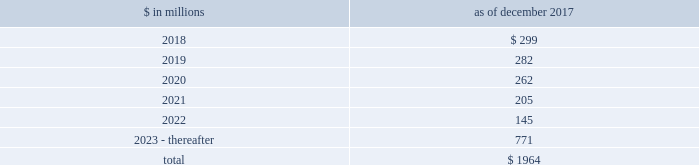The goldman sachs group , inc .
And subsidiaries notes to consolidated financial statements commercial lending .
The firm 2019s commercial lending commitments are extended to investment-grade and non-investment-grade corporate borrowers .
Commitments to investment-grade corporate borrowers are principally used for operating liquidity and general corporate purposes .
The firm also extends lending commitments in connection with contingent acquisition financing and other types of corporate lending , as well as commercial real estate financing .
Commitments that are extended for contingent acquisition financing are often intended to be short-term in nature , as borrowers often seek to replace them with other funding sources .
Sumitomo mitsui financial group , inc .
( smfg ) provides the firm with credit loss protection on certain approved loan commitments ( primarily investment-grade commercial lending commitments ) .
The notional amount of such loan commitments was $ 25.70 billion and $ 26.88 billion as of december 2017 and december 2016 , respectively .
The credit loss protection on loan commitments provided by smfg is generally limited to 95% ( 95 % ) of the first loss the firm realizes on such commitments , up to a maximum of approximately $ 950 million .
In addition , subject to the satisfaction of certain conditions , upon the firm 2019s request , smfg will provide protection for 70% ( 70 % ) of additional losses on such commitments , up to a maximum of $ 1.13 billion , of which $ 550 million and $ 768 million of protection had been provided as of december 2017 and december 2016 , respectively .
The firm also uses other financial instruments to mitigate credit risks related to certain commitments not covered by smfg .
These instruments primarily include credit default swaps that reference the same or similar underlying instrument or entity , or credit default swaps that reference a market index .
Warehouse financing .
The firm provides financing to clients who warehouse financial assets .
These arrangements are secured by the warehoused assets , primarily consisting of retail and corporate loans .
Contingent and forward starting collateralized agreements / forward starting collateralized financings contingent and forward starting collateralized agreements includes resale and securities borrowing agreements , and forward starting collateralized financings includes repurchase and secured lending agreements that settle at a future date , generally within three business days .
The firm also enters into commitments to provide contingent financing to its clients and counterparties through resale agreements .
The firm 2019s funding of these commitments depends on the satisfaction of all contractual conditions to the resale agreement and these commitments can expire unused .
Letters of credit the firm has commitments under letters of credit issued by various banks which the firm provides to counterparties in lieu of securities or cash to satisfy various collateral and margin deposit requirements .
Investment commitments investment commitments includes commitments to invest in private equity , real estate and other assets directly and through funds that the firm raises and manages .
Investment commitments included $ 2.09 billion and $ 2.10 billion as of december 2017 and december 2016 , respectively , related to commitments to invest in funds managed by the firm .
If these commitments are called , they would be funded at market value on the date of investment .
Leases the firm has contractual obligations under long-term noncancelable lease agreements for office space expiring on various dates through 2069 .
Certain agreements are subject to periodic escalation provisions for increases in real estate taxes and other charges .
The table below presents future minimum rental payments , net of minimum sublease rentals .
$ in millions december 2017 .
Rent charged to operating expenses was $ 273 million for 2017 , $ 244 million for 2016 and $ 249 million for 2015 .
Goldman sachs 2017 form 10-k 163 .
What percentage of future minimum rental payments are due after 2022? 
Computations: (771 / 1964)
Answer: 0.39257. The goldman sachs group , inc .
And subsidiaries notes to consolidated financial statements commercial lending .
The firm 2019s commercial lending commitments are extended to investment-grade and non-investment-grade corporate borrowers .
Commitments to investment-grade corporate borrowers are principally used for operating liquidity and general corporate purposes .
The firm also extends lending commitments in connection with contingent acquisition financing and other types of corporate lending , as well as commercial real estate financing .
Commitments that are extended for contingent acquisition financing are often intended to be short-term in nature , as borrowers often seek to replace them with other funding sources .
Sumitomo mitsui financial group , inc .
( smfg ) provides the firm with credit loss protection on certain approved loan commitments ( primarily investment-grade commercial lending commitments ) .
The notional amount of such loan commitments was $ 25.70 billion and $ 26.88 billion as of december 2017 and december 2016 , respectively .
The credit loss protection on loan commitments provided by smfg is generally limited to 95% ( 95 % ) of the first loss the firm realizes on such commitments , up to a maximum of approximately $ 950 million .
In addition , subject to the satisfaction of certain conditions , upon the firm 2019s request , smfg will provide protection for 70% ( 70 % ) of additional losses on such commitments , up to a maximum of $ 1.13 billion , of which $ 550 million and $ 768 million of protection had been provided as of december 2017 and december 2016 , respectively .
The firm also uses other financial instruments to mitigate credit risks related to certain commitments not covered by smfg .
These instruments primarily include credit default swaps that reference the same or similar underlying instrument or entity , or credit default swaps that reference a market index .
Warehouse financing .
The firm provides financing to clients who warehouse financial assets .
These arrangements are secured by the warehoused assets , primarily consisting of retail and corporate loans .
Contingent and forward starting collateralized agreements / forward starting collateralized financings contingent and forward starting collateralized agreements includes resale and securities borrowing agreements , and forward starting collateralized financings includes repurchase and secured lending agreements that settle at a future date , generally within three business days .
The firm also enters into commitments to provide contingent financing to its clients and counterparties through resale agreements .
The firm 2019s funding of these commitments depends on the satisfaction of all contractual conditions to the resale agreement and these commitments can expire unused .
Letters of credit the firm has commitments under letters of credit issued by various banks which the firm provides to counterparties in lieu of securities or cash to satisfy various collateral and margin deposit requirements .
Investment commitments investment commitments includes commitments to invest in private equity , real estate and other assets directly and through funds that the firm raises and manages .
Investment commitments included $ 2.09 billion and $ 2.10 billion as of december 2017 and december 2016 , respectively , related to commitments to invest in funds managed by the firm .
If these commitments are called , they would be funded at market value on the date of investment .
Leases the firm has contractual obligations under long-term noncancelable lease agreements for office space expiring on various dates through 2069 .
Certain agreements are subject to periodic escalation provisions for increases in real estate taxes and other charges .
The table below presents future minimum rental payments , net of minimum sublease rentals .
$ in millions december 2017 .
Rent charged to operating expenses was $ 273 million for 2017 , $ 244 million for 2016 and $ 249 million for 2015 .
Goldman sachs 2017 form 10-k 163 .
Rent charged to operating expenses was what percent of future minimum rental payments , net of minimum sublease rentals , for 2017? 
Computations: (273 / 1964)
Answer: 0.139. The goldman sachs group , inc .
And subsidiaries notes to consolidated financial statements commercial lending .
The firm 2019s commercial lending commitments are extended to investment-grade and non-investment-grade corporate borrowers .
Commitments to investment-grade corporate borrowers are principally used for operating liquidity and general corporate purposes .
The firm also extends lending commitments in connection with contingent acquisition financing and other types of corporate lending , as well as commercial real estate financing .
Commitments that are extended for contingent acquisition financing are often intended to be short-term in nature , as borrowers often seek to replace them with other funding sources .
Sumitomo mitsui financial group , inc .
( smfg ) provides the firm with credit loss protection on certain approved loan commitments ( primarily investment-grade commercial lending commitments ) .
The notional amount of such loan commitments was $ 25.70 billion and $ 26.88 billion as of december 2017 and december 2016 , respectively .
The credit loss protection on loan commitments provided by smfg is generally limited to 95% ( 95 % ) of the first loss the firm realizes on such commitments , up to a maximum of approximately $ 950 million .
In addition , subject to the satisfaction of certain conditions , upon the firm 2019s request , smfg will provide protection for 70% ( 70 % ) of additional losses on such commitments , up to a maximum of $ 1.13 billion , of which $ 550 million and $ 768 million of protection had been provided as of december 2017 and december 2016 , respectively .
The firm also uses other financial instruments to mitigate credit risks related to certain commitments not covered by smfg .
These instruments primarily include credit default swaps that reference the same or similar underlying instrument or entity , or credit default swaps that reference a market index .
Warehouse financing .
The firm provides financing to clients who warehouse financial assets .
These arrangements are secured by the warehoused assets , primarily consisting of retail and corporate loans .
Contingent and forward starting collateralized agreements / forward starting collateralized financings contingent and forward starting collateralized agreements includes resale and securities borrowing agreements , and forward starting collateralized financings includes repurchase and secured lending agreements that settle at a future date , generally within three business days .
The firm also enters into commitments to provide contingent financing to its clients and counterparties through resale agreements .
The firm 2019s funding of these commitments depends on the satisfaction of all contractual conditions to the resale agreement and these commitments can expire unused .
Letters of credit the firm has commitments under letters of credit issued by various banks which the firm provides to counterparties in lieu of securities or cash to satisfy various collateral and margin deposit requirements .
Investment commitments investment commitments includes commitments to invest in private equity , real estate and other assets directly and through funds that the firm raises and manages .
Investment commitments included $ 2.09 billion and $ 2.10 billion as of december 2017 and december 2016 , respectively , related to commitments to invest in funds managed by the firm .
If these commitments are called , they would be funded at market value on the date of investment .
Leases the firm has contractual obligations under long-term noncancelable lease agreements for office space expiring on various dates through 2069 .
Certain agreements are subject to periodic escalation provisions for increases in real estate taxes and other charges .
The table below presents future minimum rental payments , net of minimum sublease rentals .
$ in millions december 2017 .
Rent charged to operating expenses was $ 273 million for 2017 , $ 244 million for 2016 and $ 249 million for 2015 .
Goldman sachs 2017 form 10-k 163 .
What percentage of future minimum rental payments are due in 2019? 
Computations: (282 / 1964)
Answer: 0.14358. 